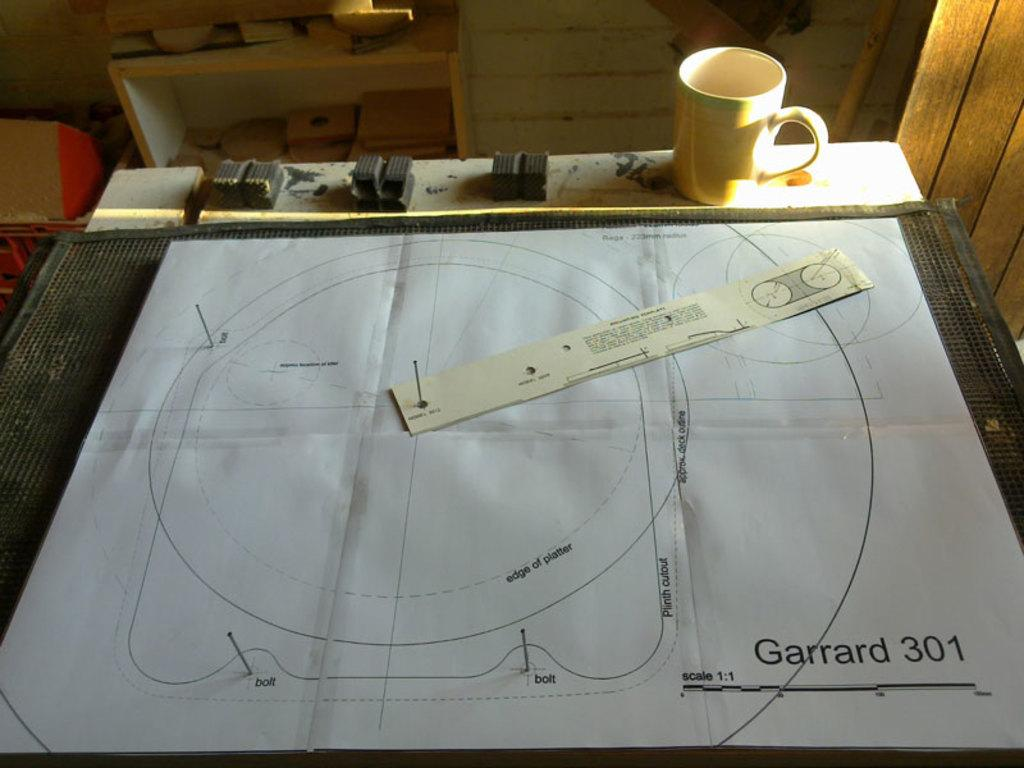<image>
Render a clear and concise summary of the photo. A blueprint in progress is labelled Garrard 301. 